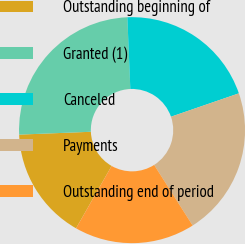Convert chart. <chart><loc_0><loc_0><loc_500><loc_500><pie_chart><fcel>Outstanding beginning of<fcel>Granted (1)<fcel>Canceled<fcel>Payments<fcel>Outstanding end of period<nl><fcel>16.12%<fcel>24.97%<fcel>20.38%<fcel>21.27%<fcel>17.26%<nl></chart> 